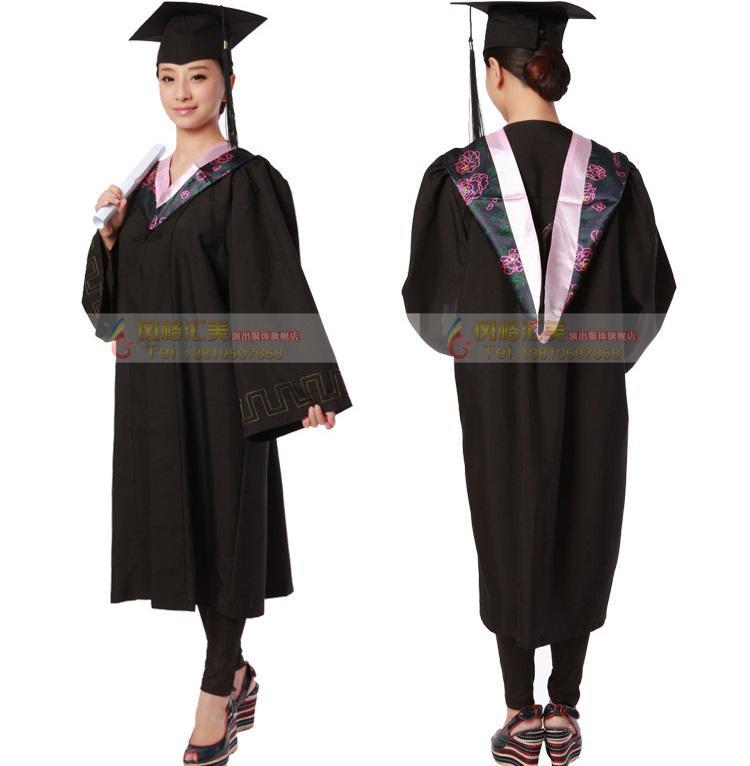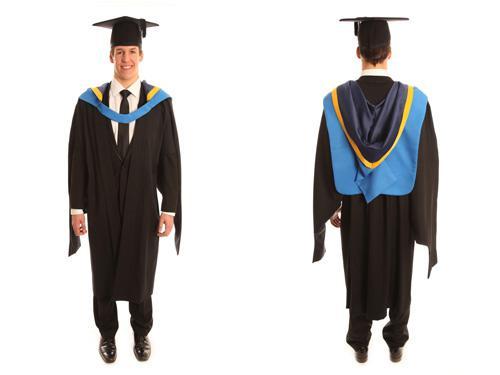The first image is the image on the left, the second image is the image on the right. Considering the images on both sides, is "There are three people in one of the images." valid? Answer yes or no. No. 